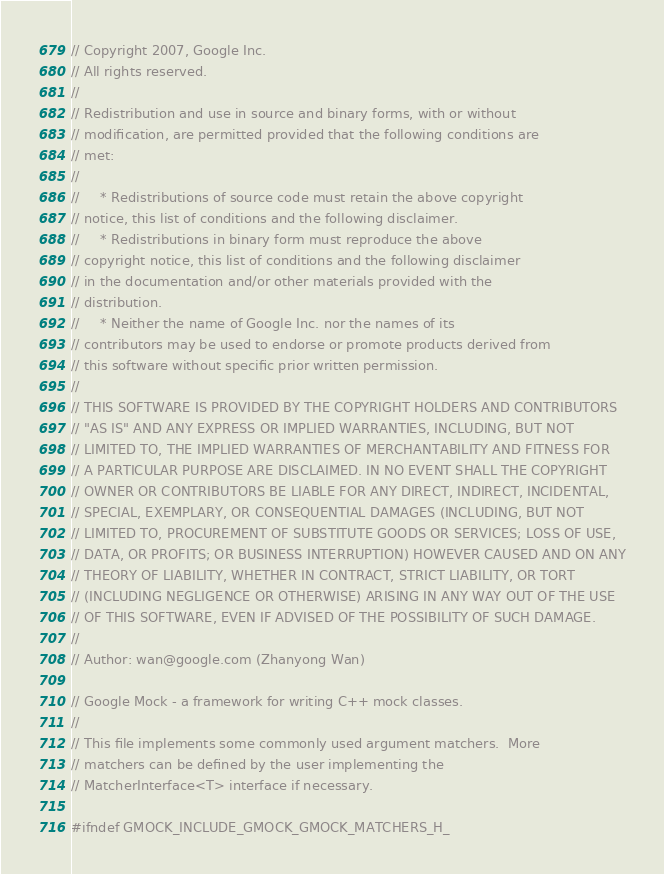<code> <loc_0><loc_0><loc_500><loc_500><_C_>// Copyright 2007, Google Inc.
// All rights reserved.
//
// Redistribution and use in source and binary forms, with or without
// modification, are permitted provided that the following conditions are
// met:
//
//     * Redistributions of source code must retain the above copyright
// notice, this list of conditions and the following disclaimer.
//     * Redistributions in binary form must reproduce the above
// copyright notice, this list of conditions and the following disclaimer
// in the documentation and/or other materials provided with the
// distribution.
//     * Neither the name of Google Inc. nor the names of its
// contributors may be used to endorse or promote products derived from
// this software without specific prior written permission.
//
// THIS SOFTWARE IS PROVIDED BY THE COPYRIGHT HOLDERS AND CONTRIBUTORS
// "AS IS" AND ANY EXPRESS OR IMPLIED WARRANTIES, INCLUDING, BUT NOT
// LIMITED TO, THE IMPLIED WARRANTIES OF MERCHANTABILITY AND FITNESS FOR
// A PARTICULAR PURPOSE ARE DISCLAIMED. IN NO EVENT SHALL THE COPYRIGHT
// OWNER OR CONTRIBUTORS BE LIABLE FOR ANY DIRECT, INDIRECT, INCIDENTAL,
// SPECIAL, EXEMPLARY, OR CONSEQUENTIAL DAMAGES (INCLUDING, BUT NOT
// LIMITED TO, PROCUREMENT OF SUBSTITUTE GOODS OR SERVICES; LOSS OF USE,
// DATA, OR PROFITS; OR BUSINESS INTERRUPTION) HOWEVER CAUSED AND ON ANY
// THEORY OF LIABILITY, WHETHER IN CONTRACT, STRICT LIABILITY, OR TORT
// (INCLUDING NEGLIGENCE OR OTHERWISE) ARISING IN ANY WAY OUT OF THE USE
// OF THIS SOFTWARE, EVEN IF ADVISED OF THE POSSIBILITY OF SUCH DAMAGE.
//
// Author: wan@google.com (Zhanyong Wan)

// Google Mock - a framework for writing C++ mock classes.
//
// This file implements some commonly used argument matchers.  More
// matchers can be defined by the user implementing the
// MatcherInterface<T> interface if necessary.

#ifndef GMOCK_INCLUDE_GMOCK_GMOCK_MATCHERS_H_</code> 